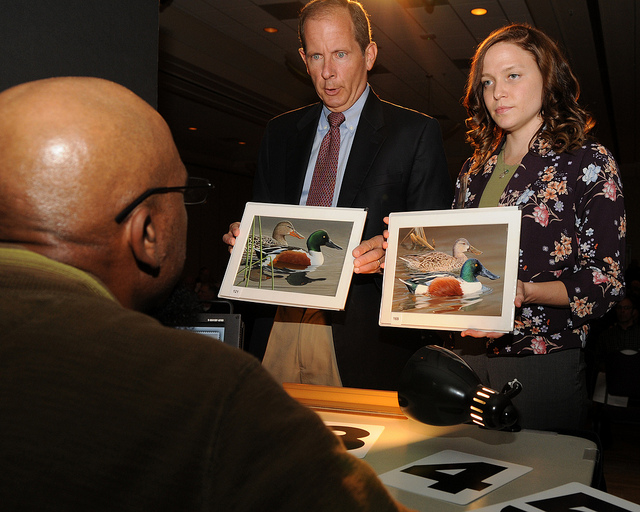Extract all visible text content from this image. B 4 5 